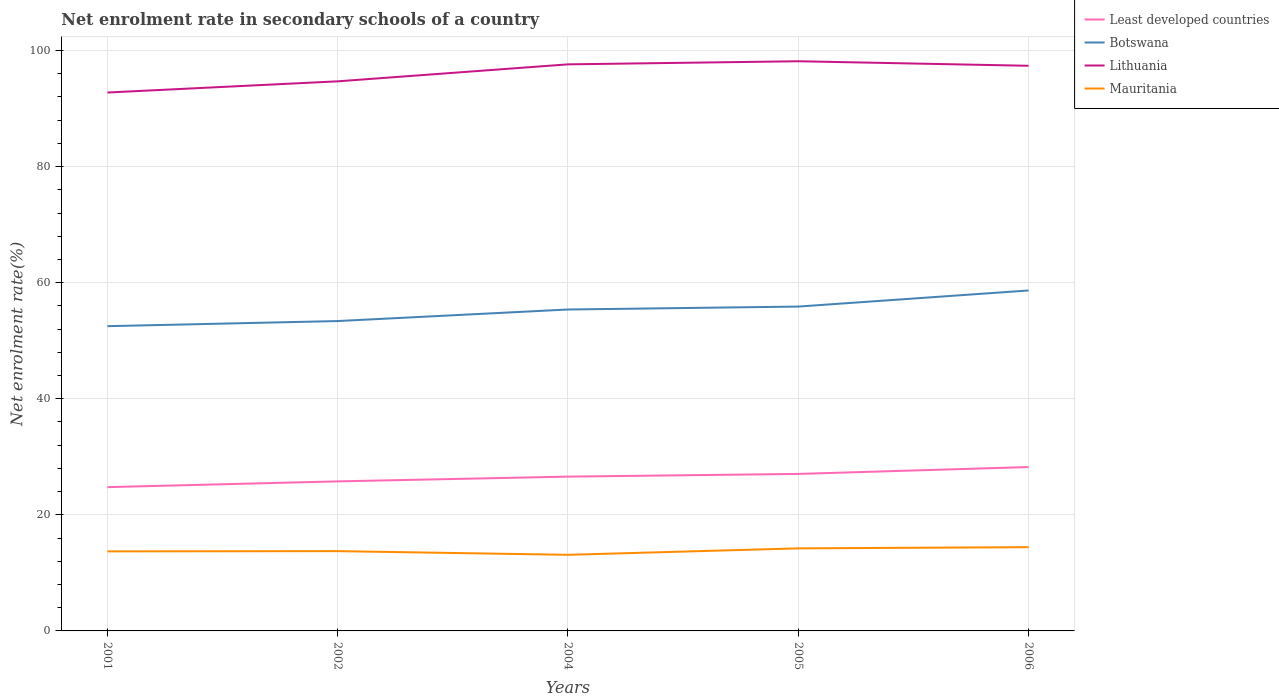How many different coloured lines are there?
Provide a succinct answer. 4. Does the line corresponding to Least developed countries intersect with the line corresponding to Botswana?
Offer a terse response. No. Is the number of lines equal to the number of legend labels?
Provide a succinct answer. Yes. Across all years, what is the maximum net enrolment rate in secondary schools in Lithuania?
Offer a very short reply. 92.76. What is the total net enrolment rate in secondary schools in Mauritania in the graph?
Provide a short and direct response. -1.11. What is the difference between the highest and the second highest net enrolment rate in secondary schools in Mauritania?
Your answer should be very brief. 1.32. Does the graph contain any zero values?
Make the answer very short. No. Does the graph contain grids?
Your response must be concise. Yes. What is the title of the graph?
Your response must be concise. Net enrolment rate in secondary schools of a country. What is the label or title of the Y-axis?
Ensure brevity in your answer.  Net enrolment rate(%). What is the Net enrolment rate(%) in Least developed countries in 2001?
Keep it short and to the point. 24.77. What is the Net enrolment rate(%) in Botswana in 2001?
Provide a succinct answer. 52.5. What is the Net enrolment rate(%) of Lithuania in 2001?
Offer a terse response. 92.76. What is the Net enrolment rate(%) of Mauritania in 2001?
Your answer should be compact. 13.71. What is the Net enrolment rate(%) in Least developed countries in 2002?
Keep it short and to the point. 25.77. What is the Net enrolment rate(%) of Botswana in 2002?
Your answer should be very brief. 53.39. What is the Net enrolment rate(%) of Lithuania in 2002?
Offer a very short reply. 94.69. What is the Net enrolment rate(%) of Mauritania in 2002?
Give a very brief answer. 13.75. What is the Net enrolment rate(%) of Least developed countries in 2004?
Your answer should be compact. 26.58. What is the Net enrolment rate(%) in Botswana in 2004?
Make the answer very short. 55.38. What is the Net enrolment rate(%) in Lithuania in 2004?
Your answer should be very brief. 97.61. What is the Net enrolment rate(%) in Mauritania in 2004?
Offer a terse response. 13.11. What is the Net enrolment rate(%) in Least developed countries in 2005?
Give a very brief answer. 27.05. What is the Net enrolment rate(%) of Botswana in 2005?
Give a very brief answer. 55.88. What is the Net enrolment rate(%) of Lithuania in 2005?
Your answer should be very brief. 98.15. What is the Net enrolment rate(%) in Mauritania in 2005?
Your answer should be compact. 14.23. What is the Net enrolment rate(%) of Least developed countries in 2006?
Keep it short and to the point. 28.23. What is the Net enrolment rate(%) in Botswana in 2006?
Offer a terse response. 58.66. What is the Net enrolment rate(%) of Lithuania in 2006?
Offer a terse response. 97.37. What is the Net enrolment rate(%) in Mauritania in 2006?
Provide a succinct answer. 14.43. Across all years, what is the maximum Net enrolment rate(%) in Least developed countries?
Your answer should be compact. 28.23. Across all years, what is the maximum Net enrolment rate(%) in Botswana?
Provide a short and direct response. 58.66. Across all years, what is the maximum Net enrolment rate(%) in Lithuania?
Ensure brevity in your answer.  98.15. Across all years, what is the maximum Net enrolment rate(%) in Mauritania?
Make the answer very short. 14.43. Across all years, what is the minimum Net enrolment rate(%) in Least developed countries?
Make the answer very short. 24.77. Across all years, what is the minimum Net enrolment rate(%) of Botswana?
Keep it short and to the point. 52.5. Across all years, what is the minimum Net enrolment rate(%) in Lithuania?
Offer a very short reply. 92.76. Across all years, what is the minimum Net enrolment rate(%) of Mauritania?
Provide a succinct answer. 13.11. What is the total Net enrolment rate(%) in Least developed countries in the graph?
Ensure brevity in your answer.  132.4. What is the total Net enrolment rate(%) of Botswana in the graph?
Offer a very short reply. 275.81. What is the total Net enrolment rate(%) of Lithuania in the graph?
Provide a short and direct response. 480.58. What is the total Net enrolment rate(%) of Mauritania in the graph?
Offer a terse response. 69.22. What is the difference between the Net enrolment rate(%) of Least developed countries in 2001 and that in 2002?
Your answer should be compact. -0.99. What is the difference between the Net enrolment rate(%) of Botswana in 2001 and that in 2002?
Offer a terse response. -0.88. What is the difference between the Net enrolment rate(%) in Lithuania in 2001 and that in 2002?
Keep it short and to the point. -1.93. What is the difference between the Net enrolment rate(%) in Mauritania in 2001 and that in 2002?
Give a very brief answer. -0.04. What is the difference between the Net enrolment rate(%) in Least developed countries in 2001 and that in 2004?
Make the answer very short. -1.81. What is the difference between the Net enrolment rate(%) in Botswana in 2001 and that in 2004?
Offer a very short reply. -2.87. What is the difference between the Net enrolment rate(%) in Lithuania in 2001 and that in 2004?
Your answer should be compact. -4.85. What is the difference between the Net enrolment rate(%) of Mauritania in 2001 and that in 2004?
Your response must be concise. 0.59. What is the difference between the Net enrolment rate(%) of Least developed countries in 2001 and that in 2005?
Offer a terse response. -2.28. What is the difference between the Net enrolment rate(%) in Botswana in 2001 and that in 2005?
Provide a short and direct response. -3.38. What is the difference between the Net enrolment rate(%) of Lithuania in 2001 and that in 2005?
Keep it short and to the point. -5.39. What is the difference between the Net enrolment rate(%) of Mauritania in 2001 and that in 2005?
Make the answer very short. -0.52. What is the difference between the Net enrolment rate(%) in Least developed countries in 2001 and that in 2006?
Give a very brief answer. -3.46. What is the difference between the Net enrolment rate(%) in Botswana in 2001 and that in 2006?
Ensure brevity in your answer.  -6.15. What is the difference between the Net enrolment rate(%) of Lithuania in 2001 and that in 2006?
Your answer should be very brief. -4.6. What is the difference between the Net enrolment rate(%) of Mauritania in 2001 and that in 2006?
Make the answer very short. -0.72. What is the difference between the Net enrolment rate(%) in Least developed countries in 2002 and that in 2004?
Keep it short and to the point. -0.82. What is the difference between the Net enrolment rate(%) in Botswana in 2002 and that in 2004?
Your answer should be compact. -1.99. What is the difference between the Net enrolment rate(%) of Lithuania in 2002 and that in 2004?
Provide a short and direct response. -2.93. What is the difference between the Net enrolment rate(%) in Mauritania in 2002 and that in 2004?
Your answer should be compact. 0.63. What is the difference between the Net enrolment rate(%) of Least developed countries in 2002 and that in 2005?
Make the answer very short. -1.28. What is the difference between the Net enrolment rate(%) of Botswana in 2002 and that in 2005?
Make the answer very short. -2.49. What is the difference between the Net enrolment rate(%) of Lithuania in 2002 and that in 2005?
Provide a short and direct response. -3.46. What is the difference between the Net enrolment rate(%) of Mauritania in 2002 and that in 2005?
Keep it short and to the point. -0.48. What is the difference between the Net enrolment rate(%) in Least developed countries in 2002 and that in 2006?
Your answer should be very brief. -2.47. What is the difference between the Net enrolment rate(%) in Botswana in 2002 and that in 2006?
Your answer should be compact. -5.27. What is the difference between the Net enrolment rate(%) in Lithuania in 2002 and that in 2006?
Your answer should be compact. -2.68. What is the difference between the Net enrolment rate(%) in Mauritania in 2002 and that in 2006?
Your answer should be very brief. -0.68. What is the difference between the Net enrolment rate(%) of Least developed countries in 2004 and that in 2005?
Offer a terse response. -0.46. What is the difference between the Net enrolment rate(%) of Botswana in 2004 and that in 2005?
Your response must be concise. -0.5. What is the difference between the Net enrolment rate(%) of Lithuania in 2004 and that in 2005?
Keep it short and to the point. -0.53. What is the difference between the Net enrolment rate(%) of Mauritania in 2004 and that in 2005?
Offer a very short reply. -1.11. What is the difference between the Net enrolment rate(%) in Least developed countries in 2004 and that in 2006?
Give a very brief answer. -1.65. What is the difference between the Net enrolment rate(%) in Botswana in 2004 and that in 2006?
Your response must be concise. -3.28. What is the difference between the Net enrolment rate(%) of Lithuania in 2004 and that in 2006?
Provide a short and direct response. 0.25. What is the difference between the Net enrolment rate(%) of Mauritania in 2004 and that in 2006?
Your answer should be very brief. -1.32. What is the difference between the Net enrolment rate(%) of Least developed countries in 2005 and that in 2006?
Provide a succinct answer. -1.18. What is the difference between the Net enrolment rate(%) in Botswana in 2005 and that in 2006?
Keep it short and to the point. -2.77. What is the difference between the Net enrolment rate(%) of Lithuania in 2005 and that in 2006?
Give a very brief answer. 0.78. What is the difference between the Net enrolment rate(%) of Mauritania in 2005 and that in 2006?
Provide a succinct answer. -0.2. What is the difference between the Net enrolment rate(%) in Least developed countries in 2001 and the Net enrolment rate(%) in Botswana in 2002?
Keep it short and to the point. -28.61. What is the difference between the Net enrolment rate(%) in Least developed countries in 2001 and the Net enrolment rate(%) in Lithuania in 2002?
Your answer should be compact. -69.92. What is the difference between the Net enrolment rate(%) of Least developed countries in 2001 and the Net enrolment rate(%) of Mauritania in 2002?
Offer a very short reply. 11.03. What is the difference between the Net enrolment rate(%) of Botswana in 2001 and the Net enrolment rate(%) of Lithuania in 2002?
Your answer should be compact. -42.19. What is the difference between the Net enrolment rate(%) of Botswana in 2001 and the Net enrolment rate(%) of Mauritania in 2002?
Give a very brief answer. 38.76. What is the difference between the Net enrolment rate(%) in Lithuania in 2001 and the Net enrolment rate(%) in Mauritania in 2002?
Your response must be concise. 79.02. What is the difference between the Net enrolment rate(%) of Least developed countries in 2001 and the Net enrolment rate(%) of Botswana in 2004?
Your answer should be compact. -30.6. What is the difference between the Net enrolment rate(%) in Least developed countries in 2001 and the Net enrolment rate(%) in Lithuania in 2004?
Make the answer very short. -72.84. What is the difference between the Net enrolment rate(%) of Least developed countries in 2001 and the Net enrolment rate(%) of Mauritania in 2004?
Ensure brevity in your answer.  11.66. What is the difference between the Net enrolment rate(%) in Botswana in 2001 and the Net enrolment rate(%) in Lithuania in 2004?
Provide a short and direct response. -45.11. What is the difference between the Net enrolment rate(%) of Botswana in 2001 and the Net enrolment rate(%) of Mauritania in 2004?
Provide a short and direct response. 39.39. What is the difference between the Net enrolment rate(%) of Lithuania in 2001 and the Net enrolment rate(%) of Mauritania in 2004?
Your answer should be compact. 79.65. What is the difference between the Net enrolment rate(%) in Least developed countries in 2001 and the Net enrolment rate(%) in Botswana in 2005?
Offer a very short reply. -31.11. What is the difference between the Net enrolment rate(%) in Least developed countries in 2001 and the Net enrolment rate(%) in Lithuania in 2005?
Ensure brevity in your answer.  -73.38. What is the difference between the Net enrolment rate(%) of Least developed countries in 2001 and the Net enrolment rate(%) of Mauritania in 2005?
Your response must be concise. 10.55. What is the difference between the Net enrolment rate(%) of Botswana in 2001 and the Net enrolment rate(%) of Lithuania in 2005?
Make the answer very short. -45.64. What is the difference between the Net enrolment rate(%) of Botswana in 2001 and the Net enrolment rate(%) of Mauritania in 2005?
Offer a very short reply. 38.28. What is the difference between the Net enrolment rate(%) of Lithuania in 2001 and the Net enrolment rate(%) of Mauritania in 2005?
Your answer should be very brief. 78.54. What is the difference between the Net enrolment rate(%) of Least developed countries in 2001 and the Net enrolment rate(%) of Botswana in 2006?
Your answer should be compact. -33.88. What is the difference between the Net enrolment rate(%) in Least developed countries in 2001 and the Net enrolment rate(%) in Lithuania in 2006?
Give a very brief answer. -72.59. What is the difference between the Net enrolment rate(%) of Least developed countries in 2001 and the Net enrolment rate(%) of Mauritania in 2006?
Ensure brevity in your answer.  10.34. What is the difference between the Net enrolment rate(%) of Botswana in 2001 and the Net enrolment rate(%) of Lithuania in 2006?
Give a very brief answer. -44.86. What is the difference between the Net enrolment rate(%) of Botswana in 2001 and the Net enrolment rate(%) of Mauritania in 2006?
Your answer should be very brief. 38.07. What is the difference between the Net enrolment rate(%) in Lithuania in 2001 and the Net enrolment rate(%) in Mauritania in 2006?
Provide a succinct answer. 78.33. What is the difference between the Net enrolment rate(%) in Least developed countries in 2002 and the Net enrolment rate(%) in Botswana in 2004?
Your answer should be compact. -29.61. What is the difference between the Net enrolment rate(%) of Least developed countries in 2002 and the Net enrolment rate(%) of Lithuania in 2004?
Offer a terse response. -71.85. What is the difference between the Net enrolment rate(%) in Least developed countries in 2002 and the Net enrolment rate(%) in Mauritania in 2004?
Provide a short and direct response. 12.65. What is the difference between the Net enrolment rate(%) of Botswana in 2002 and the Net enrolment rate(%) of Lithuania in 2004?
Your response must be concise. -44.23. What is the difference between the Net enrolment rate(%) of Botswana in 2002 and the Net enrolment rate(%) of Mauritania in 2004?
Make the answer very short. 40.27. What is the difference between the Net enrolment rate(%) of Lithuania in 2002 and the Net enrolment rate(%) of Mauritania in 2004?
Offer a very short reply. 81.58. What is the difference between the Net enrolment rate(%) of Least developed countries in 2002 and the Net enrolment rate(%) of Botswana in 2005?
Your answer should be compact. -30.12. What is the difference between the Net enrolment rate(%) of Least developed countries in 2002 and the Net enrolment rate(%) of Lithuania in 2005?
Make the answer very short. -72.38. What is the difference between the Net enrolment rate(%) in Least developed countries in 2002 and the Net enrolment rate(%) in Mauritania in 2005?
Offer a very short reply. 11.54. What is the difference between the Net enrolment rate(%) in Botswana in 2002 and the Net enrolment rate(%) in Lithuania in 2005?
Your answer should be compact. -44.76. What is the difference between the Net enrolment rate(%) of Botswana in 2002 and the Net enrolment rate(%) of Mauritania in 2005?
Your response must be concise. 39.16. What is the difference between the Net enrolment rate(%) in Lithuania in 2002 and the Net enrolment rate(%) in Mauritania in 2005?
Your answer should be very brief. 80.46. What is the difference between the Net enrolment rate(%) in Least developed countries in 2002 and the Net enrolment rate(%) in Botswana in 2006?
Ensure brevity in your answer.  -32.89. What is the difference between the Net enrolment rate(%) of Least developed countries in 2002 and the Net enrolment rate(%) of Lithuania in 2006?
Your response must be concise. -71.6. What is the difference between the Net enrolment rate(%) in Least developed countries in 2002 and the Net enrolment rate(%) in Mauritania in 2006?
Give a very brief answer. 11.34. What is the difference between the Net enrolment rate(%) in Botswana in 2002 and the Net enrolment rate(%) in Lithuania in 2006?
Offer a very short reply. -43.98. What is the difference between the Net enrolment rate(%) in Botswana in 2002 and the Net enrolment rate(%) in Mauritania in 2006?
Offer a very short reply. 38.96. What is the difference between the Net enrolment rate(%) of Lithuania in 2002 and the Net enrolment rate(%) of Mauritania in 2006?
Offer a very short reply. 80.26. What is the difference between the Net enrolment rate(%) of Least developed countries in 2004 and the Net enrolment rate(%) of Botswana in 2005?
Offer a terse response. -29.3. What is the difference between the Net enrolment rate(%) of Least developed countries in 2004 and the Net enrolment rate(%) of Lithuania in 2005?
Your answer should be very brief. -71.56. What is the difference between the Net enrolment rate(%) in Least developed countries in 2004 and the Net enrolment rate(%) in Mauritania in 2005?
Offer a terse response. 12.36. What is the difference between the Net enrolment rate(%) in Botswana in 2004 and the Net enrolment rate(%) in Lithuania in 2005?
Provide a short and direct response. -42.77. What is the difference between the Net enrolment rate(%) in Botswana in 2004 and the Net enrolment rate(%) in Mauritania in 2005?
Offer a very short reply. 41.15. What is the difference between the Net enrolment rate(%) in Lithuania in 2004 and the Net enrolment rate(%) in Mauritania in 2005?
Offer a very short reply. 83.39. What is the difference between the Net enrolment rate(%) of Least developed countries in 2004 and the Net enrolment rate(%) of Botswana in 2006?
Offer a terse response. -32.07. What is the difference between the Net enrolment rate(%) in Least developed countries in 2004 and the Net enrolment rate(%) in Lithuania in 2006?
Offer a terse response. -70.78. What is the difference between the Net enrolment rate(%) in Least developed countries in 2004 and the Net enrolment rate(%) in Mauritania in 2006?
Make the answer very short. 12.15. What is the difference between the Net enrolment rate(%) of Botswana in 2004 and the Net enrolment rate(%) of Lithuania in 2006?
Your answer should be compact. -41.99. What is the difference between the Net enrolment rate(%) of Botswana in 2004 and the Net enrolment rate(%) of Mauritania in 2006?
Provide a succinct answer. 40.95. What is the difference between the Net enrolment rate(%) in Lithuania in 2004 and the Net enrolment rate(%) in Mauritania in 2006?
Provide a succinct answer. 83.18. What is the difference between the Net enrolment rate(%) in Least developed countries in 2005 and the Net enrolment rate(%) in Botswana in 2006?
Your response must be concise. -31.61. What is the difference between the Net enrolment rate(%) of Least developed countries in 2005 and the Net enrolment rate(%) of Lithuania in 2006?
Offer a very short reply. -70.32. What is the difference between the Net enrolment rate(%) of Least developed countries in 2005 and the Net enrolment rate(%) of Mauritania in 2006?
Your answer should be compact. 12.62. What is the difference between the Net enrolment rate(%) of Botswana in 2005 and the Net enrolment rate(%) of Lithuania in 2006?
Your answer should be very brief. -41.49. What is the difference between the Net enrolment rate(%) in Botswana in 2005 and the Net enrolment rate(%) in Mauritania in 2006?
Give a very brief answer. 41.45. What is the difference between the Net enrolment rate(%) of Lithuania in 2005 and the Net enrolment rate(%) of Mauritania in 2006?
Provide a short and direct response. 83.72. What is the average Net enrolment rate(%) in Least developed countries per year?
Make the answer very short. 26.48. What is the average Net enrolment rate(%) of Botswana per year?
Your response must be concise. 55.16. What is the average Net enrolment rate(%) in Lithuania per year?
Your answer should be very brief. 96.12. What is the average Net enrolment rate(%) of Mauritania per year?
Provide a succinct answer. 13.84. In the year 2001, what is the difference between the Net enrolment rate(%) in Least developed countries and Net enrolment rate(%) in Botswana?
Offer a terse response. -27.73. In the year 2001, what is the difference between the Net enrolment rate(%) of Least developed countries and Net enrolment rate(%) of Lithuania?
Keep it short and to the point. -67.99. In the year 2001, what is the difference between the Net enrolment rate(%) of Least developed countries and Net enrolment rate(%) of Mauritania?
Provide a succinct answer. 11.07. In the year 2001, what is the difference between the Net enrolment rate(%) in Botswana and Net enrolment rate(%) in Lithuania?
Your response must be concise. -40.26. In the year 2001, what is the difference between the Net enrolment rate(%) in Botswana and Net enrolment rate(%) in Mauritania?
Your answer should be very brief. 38.8. In the year 2001, what is the difference between the Net enrolment rate(%) in Lithuania and Net enrolment rate(%) in Mauritania?
Keep it short and to the point. 79.06. In the year 2002, what is the difference between the Net enrolment rate(%) of Least developed countries and Net enrolment rate(%) of Botswana?
Your answer should be compact. -27.62. In the year 2002, what is the difference between the Net enrolment rate(%) of Least developed countries and Net enrolment rate(%) of Lithuania?
Keep it short and to the point. -68.92. In the year 2002, what is the difference between the Net enrolment rate(%) of Least developed countries and Net enrolment rate(%) of Mauritania?
Offer a terse response. 12.02. In the year 2002, what is the difference between the Net enrolment rate(%) of Botswana and Net enrolment rate(%) of Lithuania?
Offer a terse response. -41.3. In the year 2002, what is the difference between the Net enrolment rate(%) of Botswana and Net enrolment rate(%) of Mauritania?
Ensure brevity in your answer.  39.64. In the year 2002, what is the difference between the Net enrolment rate(%) of Lithuania and Net enrolment rate(%) of Mauritania?
Make the answer very short. 80.94. In the year 2004, what is the difference between the Net enrolment rate(%) in Least developed countries and Net enrolment rate(%) in Botswana?
Keep it short and to the point. -28.79. In the year 2004, what is the difference between the Net enrolment rate(%) in Least developed countries and Net enrolment rate(%) in Lithuania?
Offer a very short reply. -71.03. In the year 2004, what is the difference between the Net enrolment rate(%) of Least developed countries and Net enrolment rate(%) of Mauritania?
Your answer should be compact. 13.47. In the year 2004, what is the difference between the Net enrolment rate(%) of Botswana and Net enrolment rate(%) of Lithuania?
Give a very brief answer. -42.24. In the year 2004, what is the difference between the Net enrolment rate(%) of Botswana and Net enrolment rate(%) of Mauritania?
Offer a terse response. 42.26. In the year 2004, what is the difference between the Net enrolment rate(%) in Lithuania and Net enrolment rate(%) in Mauritania?
Offer a very short reply. 84.5. In the year 2005, what is the difference between the Net enrolment rate(%) of Least developed countries and Net enrolment rate(%) of Botswana?
Your response must be concise. -28.83. In the year 2005, what is the difference between the Net enrolment rate(%) of Least developed countries and Net enrolment rate(%) of Lithuania?
Provide a short and direct response. -71.1. In the year 2005, what is the difference between the Net enrolment rate(%) in Least developed countries and Net enrolment rate(%) in Mauritania?
Give a very brief answer. 12.82. In the year 2005, what is the difference between the Net enrolment rate(%) of Botswana and Net enrolment rate(%) of Lithuania?
Your answer should be compact. -42.27. In the year 2005, what is the difference between the Net enrolment rate(%) in Botswana and Net enrolment rate(%) in Mauritania?
Your response must be concise. 41.66. In the year 2005, what is the difference between the Net enrolment rate(%) of Lithuania and Net enrolment rate(%) of Mauritania?
Your answer should be compact. 83.92. In the year 2006, what is the difference between the Net enrolment rate(%) of Least developed countries and Net enrolment rate(%) of Botswana?
Your answer should be compact. -30.42. In the year 2006, what is the difference between the Net enrolment rate(%) in Least developed countries and Net enrolment rate(%) in Lithuania?
Your answer should be very brief. -69.13. In the year 2006, what is the difference between the Net enrolment rate(%) in Least developed countries and Net enrolment rate(%) in Mauritania?
Offer a terse response. 13.8. In the year 2006, what is the difference between the Net enrolment rate(%) in Botswana and Net enrolment rate(%) in Lithuania?
Offer a terse response. -38.71. In the year 2006, what is the difference between the Net enrolment rate(%) in Botswana and Net enrolment rate(%) in Mauritania?
Keep it short and to the point. 44.22. In the year 2006, what is the difference between the Net enrolment rate(%) in Lithuania and Net enrolment rate(%) in Mauritania?
Keep it short and to the point. 82.94. What is the ratio of the Net enrolment rate(%) in Least developed countries in 2001 to that in 2002?
Your answer should be very brief. 0.96. What is the ratio of the Net enrolment rate(%) of Botswana in 2001 to that in 2002?
Keep it short and to the point. 0.98. What is the ratio of the Net enrolment rate(%) in Lithuania in 2001 to that in 2002?
Give a very brief answer. 0.98. What is the ratio of the Net enrolment rate(%) of Least developed countries in 2001 to that in 2004?
Offer a terse response. 0.93. What is the ratio of the Net enrolment rate(%) of Botswana in 2001 to that in 2004?
Provide a succinct answer. 0.95. What is the ratio of the Net enrolment rate(%) in Lithuania in 2001 to that in 2004?
Offer a terse response. 0.95. What is the ratio of the Net enrolment rate(%) of Mauritania in 2001 to that in 2004?
Offer a very short reply. 1.05. What is the ratio of the Net enrolment rate(%) of Least developed countries in 2001 to that in 2005?
Ensure brevity in your answer.  0.92. What is the ratio of the Net enrolment rate(%) of Botswana in 2001 to that in 2005?
Your answer should be very brief. 0.94. What is the ratio of the Net enrolment rate(%) of Lithuania in 2001 to that in 2005?
Make the answer very short. 0.95. What is the ratio of the Net enrolment rate(%) of Mauritania in 2001 to that in 2005?
Your answer should be very brief. 0.96. What is the ratio of the Net enrolment rate(%) in Least developed countries in 2001 to that in 2006?
Your answer should be compact. 0.88. What is the ratio of the Net enrolment rate(%) in Botswana in 2001 to that in 2006?
Your answer should be compact. 0.9. What is the ratio of the Net enrolment rate(%) of Lithuania in 2001 to that in 2006?
Provide a succinct answer. 0.95. What is the ratio of the Net enrolment rate(%) of Mauritania in 2001 to that in 2006?
Ensure brevity in your answer.  0.95. What is the ratio of the Net enrolment rate(%) in Least developed countries in 2002 to that in 2004?
Offer a very short reply. 0.97. What is the ratio of the Net enrolment rate(%) in Botswana in 2002 to that in 2004?
Provide a succinct answer. 0.96. What is the ratio of the Net enrolment rate(%) in Mauritania in 2002 to that in 2004?
Your answer should be very brief. 1.05. What is the ratio of the Net enrolment rate(%) of Least developed countries in 2002 to that in 2005?
Ensure brevity in your answer.  0.95. What is the ratio of the Net enrolment rate(%) of Botswana in 2002 to that in 2005?
Your answer should be very brief. 0.96. What is the ratio of the Net enrolment rate(%) of Lithuania in 2002 to that in 2005?
Provide a short and direct response. 0.96. What is the ratio of the Net enrolment rate(%) in Mauritania in 2002 to that in 2005?
Give a very brief answer. 0.97. What is the ratio of the Net enrolment rate(%) of Least developed countries in 2002 to that in 2006?
Provide a short and direct response. 0.91. What is the ratio of the Net enrolment rate(%) in Botswana in 2002 to that in 2006?
Provide a succinct answer. 0.91. What is the ratio of the Net enrolment rate(%) in Lithuania in 2002 to that in 2006?
Provide a succinct answer. 0.97. What is the ratio of the Net enrolment rate(%) in Mauritania in 2002 to that in 2006?
Your response must be concise. 0.95. What is the ratio of the Net enrolment rate(%) in Least developed countries in 2004 to that in 2005?
Your response must be concise. 0.98. What is the ratio of the Net enrolment rate(%) of Lithuania in 2004 to that in 2005?
Your answer should be compact. 0.99. What is the ratio of the Net enrolment rate(%) of Mauritania in 2004 to that in 2005?
Offer a very short reply. 0.92. What is the ratio of the Net enrolment rate(%) in Least developed countries in 2004 to that in 2006?
Ensure brevity in your answer.  0.94. What is the ratio of the Net enrolment rate(%) of Botswana in 2004 to that in 2006?
Ensure brevity in your answer.  0.94. What is the ratio of the Net enrolment rate(%) in Lithuania in 2004 to that in 2006?
Your response must be concise. 1. What is the ratio of the Net enrolment rate(%) in Mauritania in 2004 to that in 2006?
Offer a terse response. 0.91. What is the ratio of the Net enrolment rate(%) of Least developed countries in 2005 to that in 2006?
Offer a terse response. 0.96. What is the ratio of the Net enrolment rate(%) of Botswana in 2005 to that in 2006?
Your answer should be very brief. 0.95. What is the ratio of the Net enrolment rate(%) in Lithuania in 2005 to that in 2006?
Offer a very short reply. 1.01. What is the ratio of the Net enrolment rate(%) of Mauritania in 2005 to that in 2006?
Your response must be concise. 0.99. What is the difference between the highest and the second highest Net enrolment rate(%) in Least developed countries?
Ensure brevity in your answer.  1.18. What is the difference between the highest and the second highest Net enrolment rate(%) in Botswana?
Your answer should be very brief. 2.77. What is the difference between the highest and the second highest Net enrolment rate(%) in Lithuania?
Your answer should be very brief. 0.53. What is the difference between the highest and the second highest Net enrolment rate(%) of Mauritania?
Your answer should be very brief. 0.2. What is the difference between the highest and the lowest Net enrolment rate(%) in Least developed countries?
Make the answer very short. 3.46. What is the difference between the highest and the lowest Net enrolment rate(%) in Botswana?
Ensure brevity in your answer.  6.15. What is the difference between the highest and the lowest Net enrolment rate(%) in Lithuania?
Offer a very short reply. 5.39. What is the difference between the highest and the lowest Net enrolment rate(%) in Mauritania?
Your answer should be very brief. 1.32. 